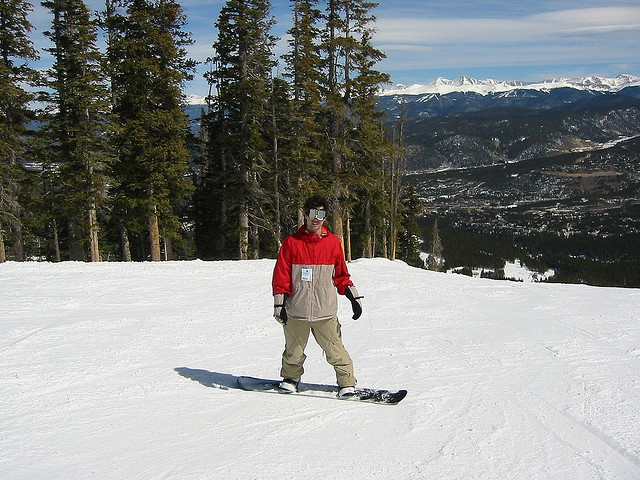Describe the objects in this image and their specific colors. I can see people in gray, darkgray, and brown tones and snowboard in gray, lightgray, black, and darkgray tones in this image. 